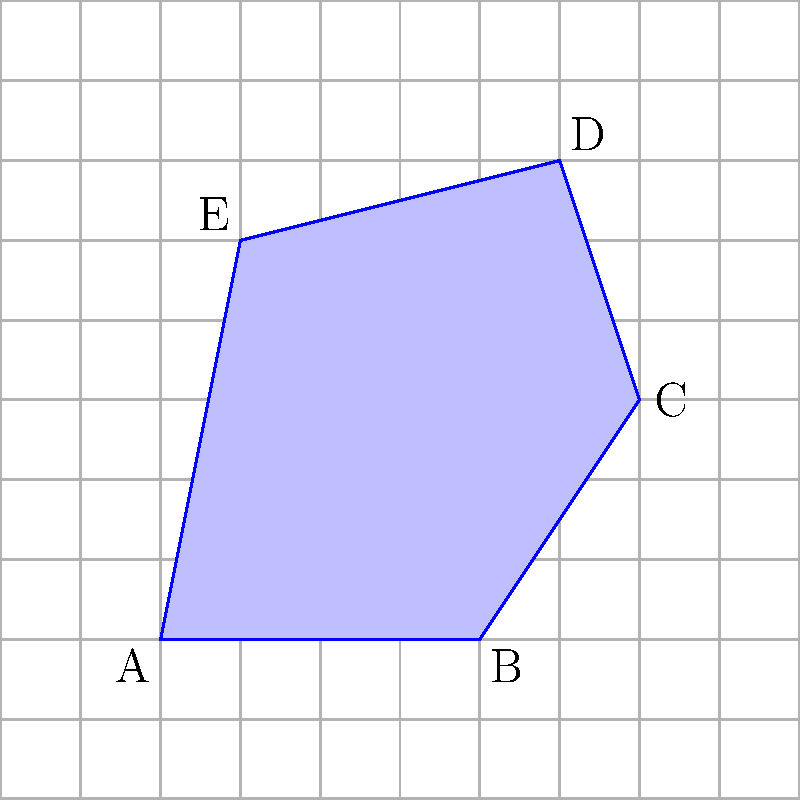The figure shows an irregular polygon ABCDE on a grid where each square has an area of 1 square unit. Estimate the area of the polygon by counting the number of whole squares and partial squares it covers. Round your answer to the nearest whole number. To estimate the area of the irregular polygon, we'll count the squares it covers:

1. Count whole squares:
   - There are approximately 20 whole squares fully within the polygon.

2. Count partial squares:
   - There are about 14 partial squares along the edges of the polygon.
   - We can estimate that these partial squares roughly equal 7 whole squares.

3. Sum up the total:
   - Whole squares: 20
   - Estimated partial squares: 7
   - Total: 20 + 7 = 27 square units

4. Round to the nearest whole number:
   - 27 is already a whole number, so no rounding is necessary.

Therefore, the estimated area of the irregular polygon is 27 square units.
Answer: 27 square units 